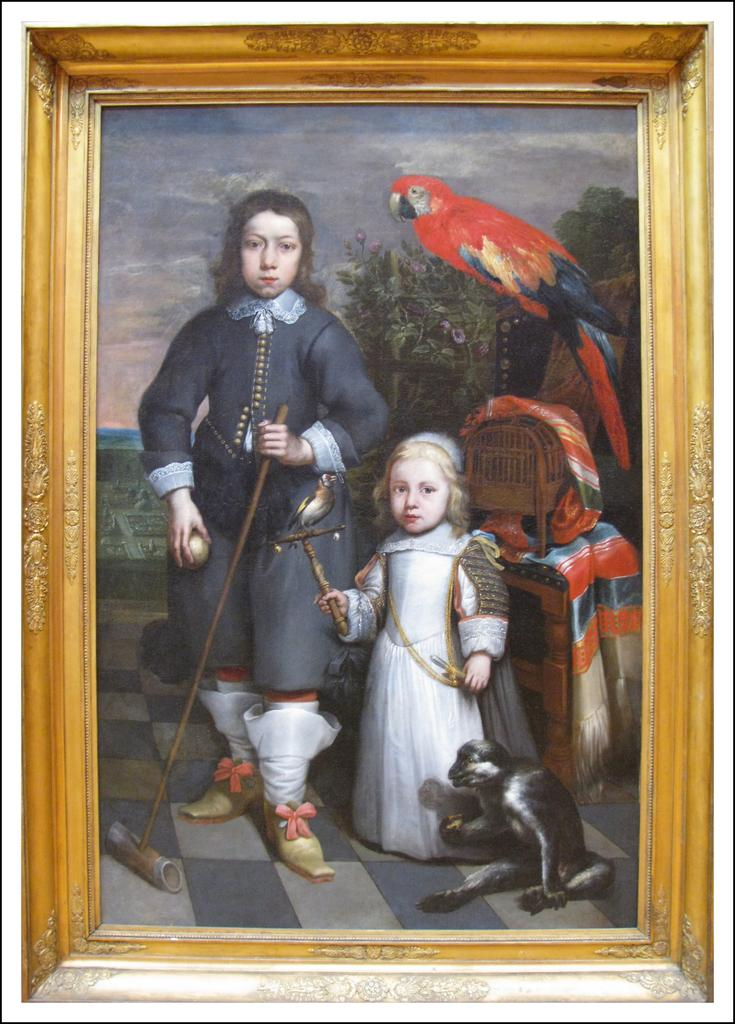What object is present in the image? There is a photo frame in the image. What is depicted within the photo frame? The photo frame contains a depiction of a person and an animal. Can you describe the setting within the photo frame's depiction? The depiction includes a stool, a cage, and a parrot. How many cakes are being served by the person in the photo frame's depiction? There are no cakes present in the photo frame's depiction; it features a person, an animal, a stool, a cage, and a parrot. 